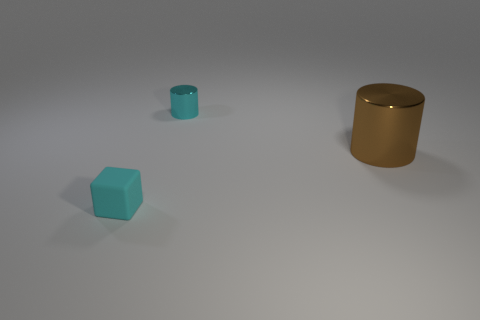How many big metallic objects have the same color as the small matte thing?
Offer a very short reply. 0. What number of things are cubes or cyan objects that are behind the brown shiny thing?
Your response must be concise. 2. What color is the big metal cylinder?
Offer a terse response. Brown. The object that is on the left side of the tiny metal thing is what color?
Provide a succinct answer. Cyan. There is a small thing left of the small cylinder; how many small matte objects are in front of it?
Provide a short and direct response. 0. There is a matte cube; is its size the same as the cylinder left of the large brown thing?
Offer a terse response. Yes. Is there a cyan metallic thing of the same size as the cyan block?
Give a very brief answer. Yes. How many things are either small metallic things or blue matte cylinders?
Your response must be concise. 1. There is a shiny thing left of the brown shiny cylinder; does it have the same size as the cyan object in front of the brown cylinder?
Offer a very short reply. Yes. Is there another big brown object that has the same shape as the brown object?
Make the answer very short. No. 